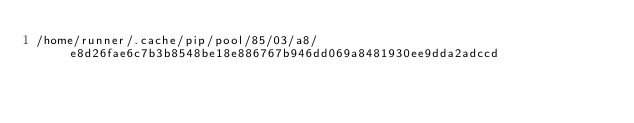<code> <loc_0><loc_0><loc_500><loc_500><_Python_>/home/runner/.cache/pip/pool/85/03/a8/e8d26fae6c7b3b8548be18e886767b946dd069a8481930ee9dda2adccd</code> 